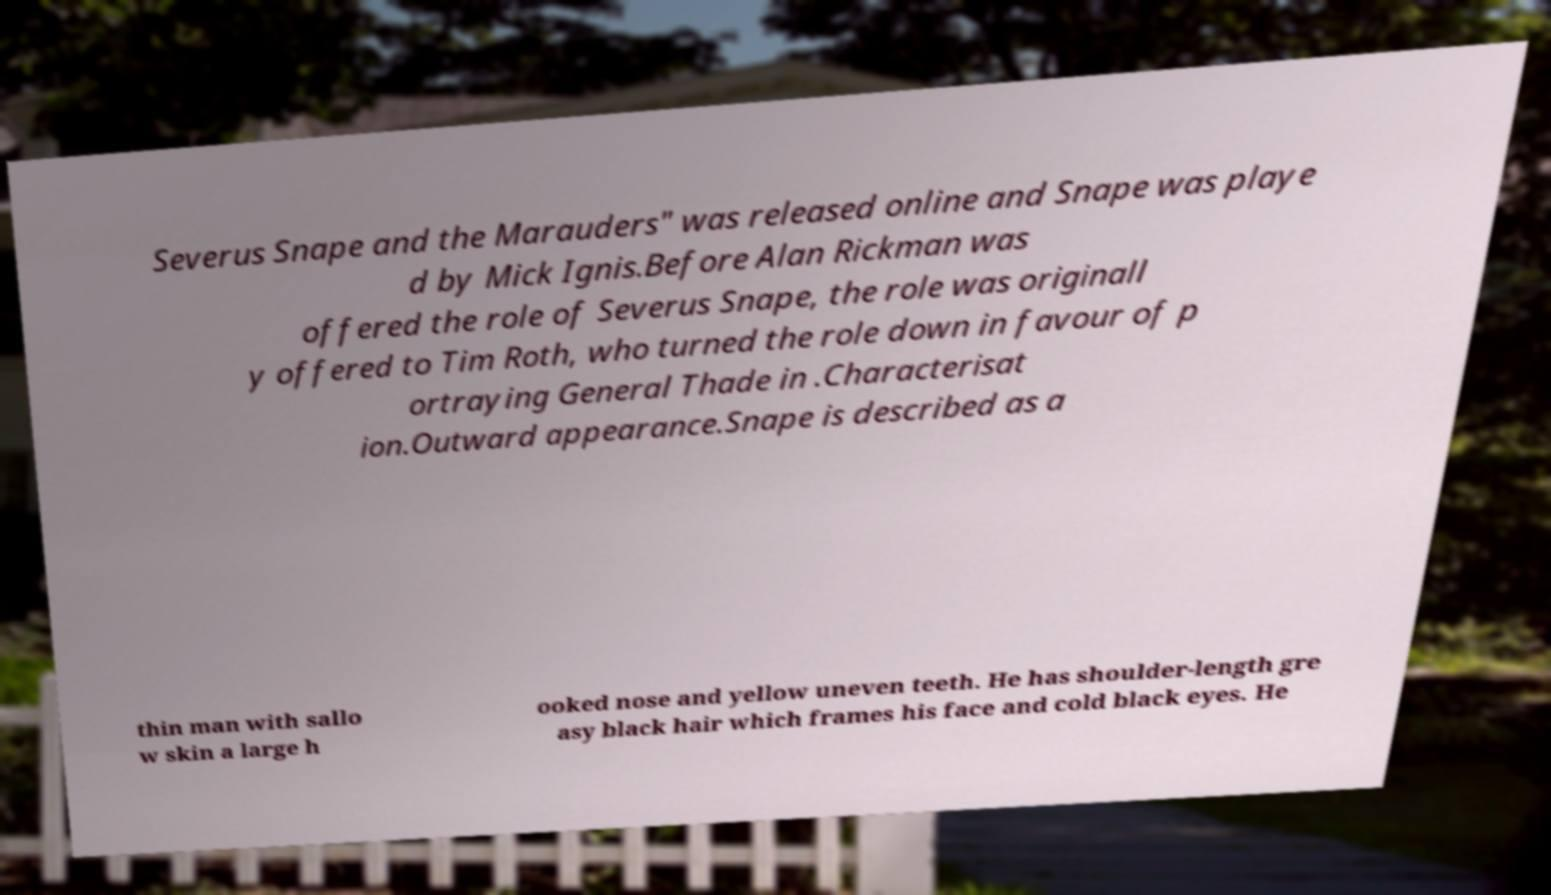Could you extract and type out the text from this image? Severus Snape and the Marauders" was released online and Snape was playe d by Mick Ignis.Before Alan Rickman was offered the role of Severus Snape, the role was originall y offered to Tim Roth, who turned the role down in favour of p ortraying General Thade in .Characterisat ion.Outward appearance.Snape is described as a thin man with sallo w skin a large h ooked nose and yellow uneven teeth. He has shoulder-length gre asy black hair which frames his face and cold black eyes. He 